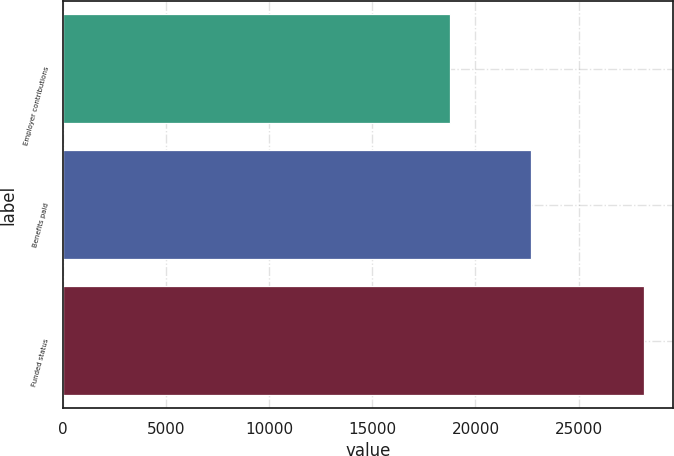Convert chart. <chart><loc_0><loc_0><loc_500><loc_500><bar_chart><fcel>Employer contributions<fcel>Benefits paid<fcel>Funded status<nl><fcel>18765<fcel>22679<fcel>28188<nl></chart> 